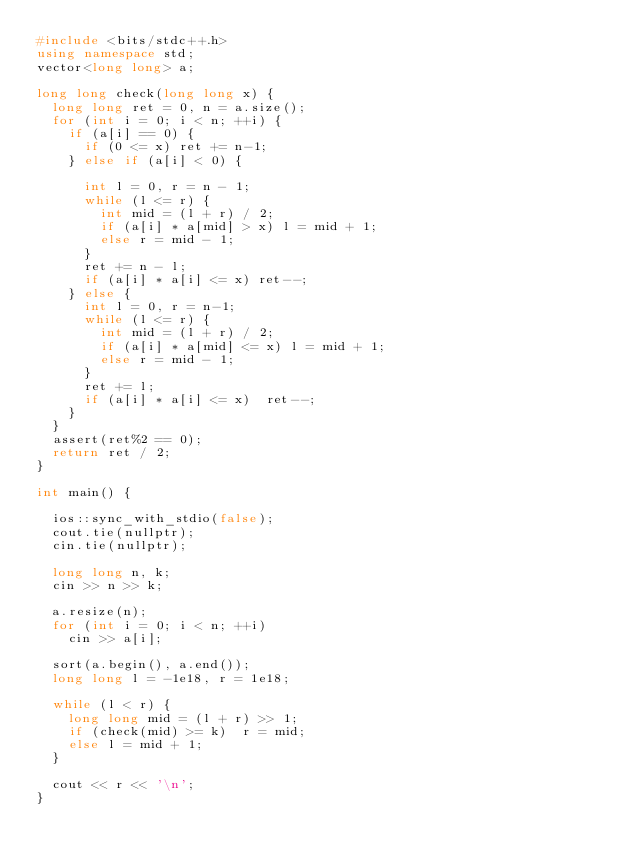<code> <loc_0><loc_0><loc_500><loc_500><_C++_>#include <bits/stdc++.h>
using namespace std;
vector<long long> a;

long long check(long long x) {
  long long ret = 0, n = a.size();
  for (int i = 0; i < n; ++i) {
    if (a[i] == 0) {
      if (0 <= x) ret += n-1;
    } else if (a[i] < 0) {

      int l = 0, r = n - 1;
      while (l <= r) {
        int mid = (l + r) / 2;
        if (a[i] * a[mid] > x) l = mid + 1;
        else r = mid - 1;
      }
      ret += n - l;
      if (a[i] * a[i] <= x) ret--;  
    } else {
      int l = 0, r = n-1;
      while (l <= r) {
        int mid = (l + r) / 2;
        if (a[i] * a[mid] <= x) l = mid + 1;
        else r = mid - 1;
      }
      ret += l;
      if (a[i] * a[i] <= x)  ret--; 
    }
  } 
  assert(ret%2 == 0); 
  return ret / 2;
}

int main() {

  ios::sync_with_stdio(false);
  cout.tie(nullptr);
  cin.tie(nullptr);

  long long n, k;
  cin >> n >> k;

  a.resize(n);
  for (int i = 0; i < n; ++i) 
    cin >> a[i];

  sort(a.begin(), a.end());
  long long l = -1e18, r = 1e18;

  while (l < r) {
    long long mid = (l + r) >> 1;
    if (check(mid) >= k)  r = mid;
    else l = mid + 1;
  }

  cout << r << '\n';
}</code> 